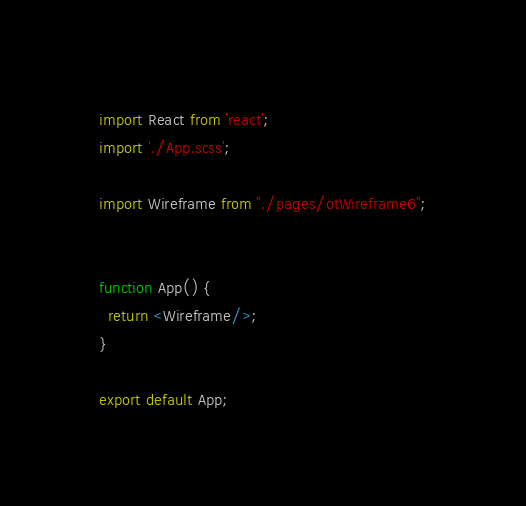<code> <loc_0><loc_0><loc_500><loc_500><_JavaScript_>import React from 'react';
import './App.scss';

import Wireframe from "./pages/otWireframe6";


function App() {
  return <Wireframe/>;
}

export default App;
</code> 